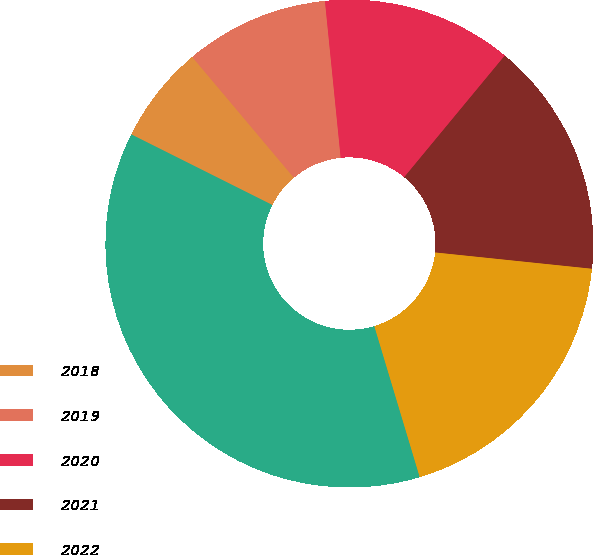Convert chart. <chart><loc_0><loc_0><loc_500><loc_500><pie_chart><fcel>2018<fcel>2019<fcel>2020<fcel>2021<fcel>2022<fcel>2023 - 2027<nl><fcel>6.48%<fcel>9.54%<fcel>12.59%<fcel>15.65%<fcel>18.7%<fcel>37.03%<nl></chart> 